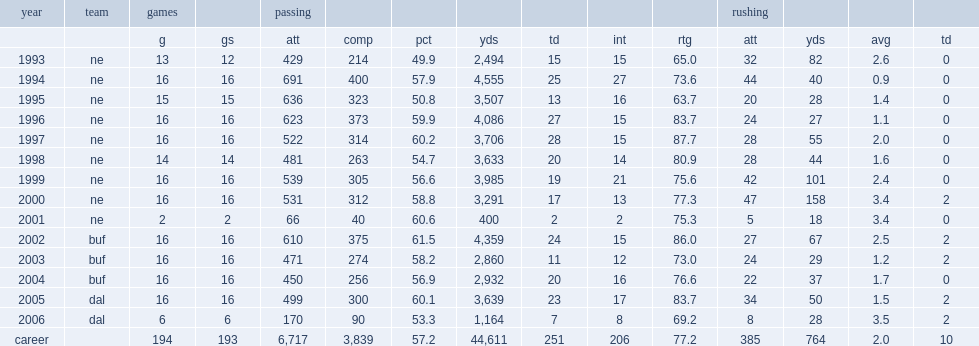How many passing yards did drew bledsoe get in 2000? 3291.0. 